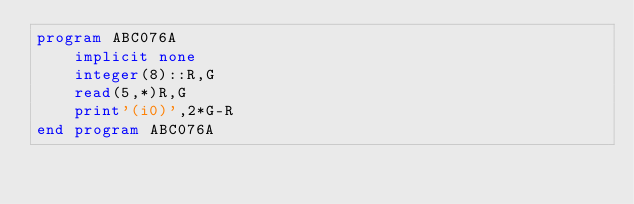Convert code to text. <code><loc_0><loc_0><loc_500><loc_500><_FORTRAN_>program ABC076A
    implicit none
    integer(8)::R,G
    read(5,*)R,G
    print'(i0)',2*G-R
end program ABC076A</code> 